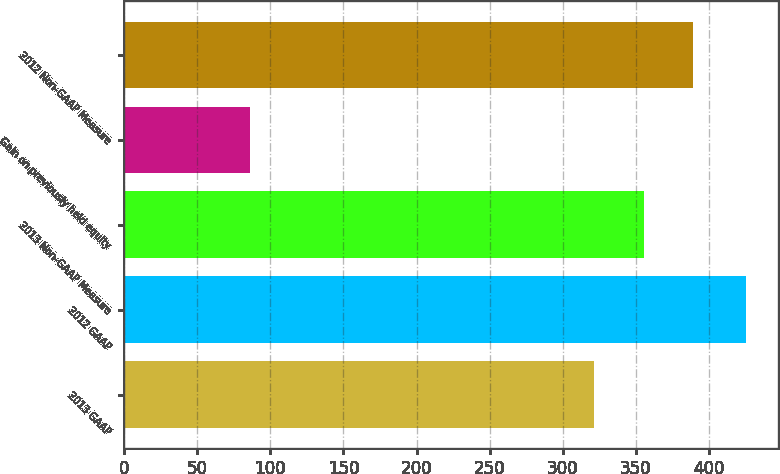<chart> <loc_0><loc_0><loc_500><loc_500><bar_chart><fcel>2013 GAAP<fcel>2012 GAAP<fcel>2013 Non-GAAP Measure<fcel>Gain on previously held equity<fcel>2012 Non-GAAP Measure<nl><fcel>321.3<fcel>425.6<fcel>355.27<fcel>85.9<fcel>389.24<nl></chart> 